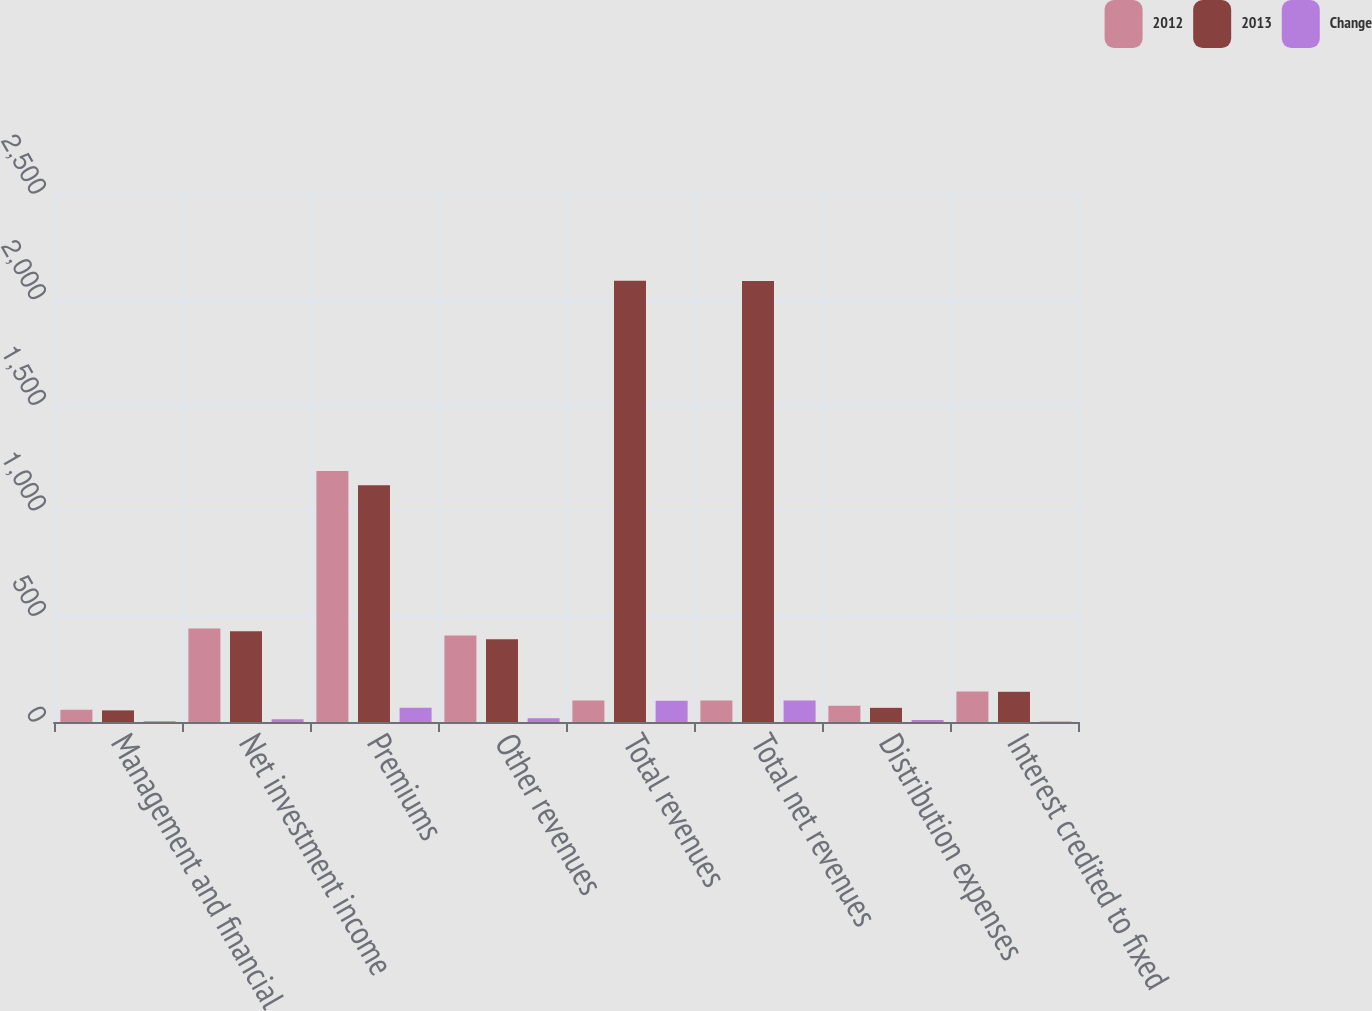Convert chart. <chart><loc_0><loc_0><loc_500><loc_500><stacked_bar_chart><ecel><fcel>Management and financial<fcel>Net investment income<fcel>Premiums<fcel>Other revenues<fcel>Total revenues<fcel>Total net revenues<fcel>Distribution expenses<fcel>Interest credited to fixed<nl><fcel>2012<fcel>58<fcel>443<fcel>1188<fcel>410<fcel>101.5<fcel>101.5<fcel>77<fcel>145<nl><fcel>2013<fcel>55<fcel>430<fcel>1121<fcel>392<fcel>2089<fcel>2088<fcel>67<fcel>143<nl><fcel>Change<fcel>3<fcel>13<fcel>67<fcel>18<fcel>101<fcel>102<fcel>10<fcel>2<nl></chart> 